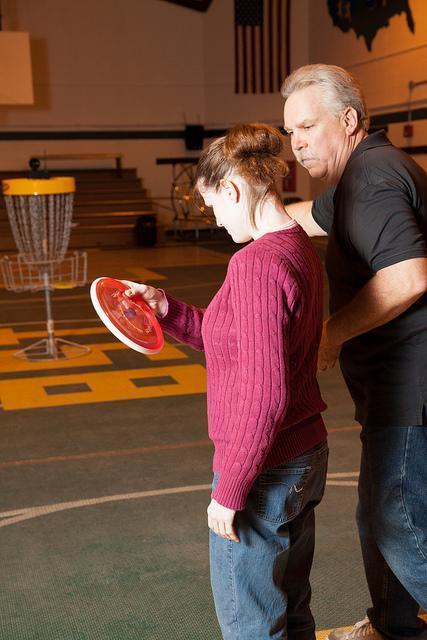How many balls are in the photo?
Give a very brief answer. 0. How many people are in the picture?
Give a very brief answer. 2. 